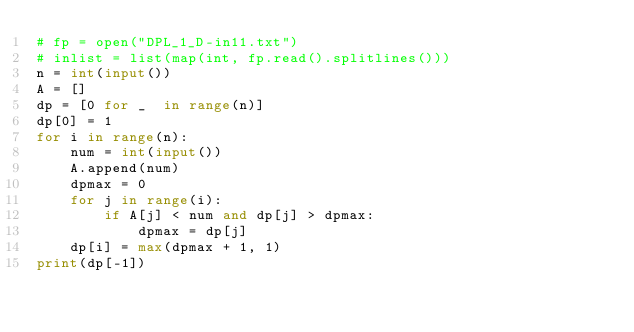<code> <loc_0><loc_0><loc_500><loc_500><_Python_># fp = open("DPL_1_D-in11.txt")
# inlist = list(map(int, fp.read().splitlines()))
n = int(input())
A = []
dp = [0 for _  in range(n)]
dp[0] = 1
for i in range(n):
    num = int(input())
    A.append(num)
    dpmax = 0
    for j in range(i):
        if A[j] < num and dp[j] > dpmax:
            dpmax = dp[j]
    dp[i] = max(dpmax + 1, 1)    
print(dp[-1])</code> 